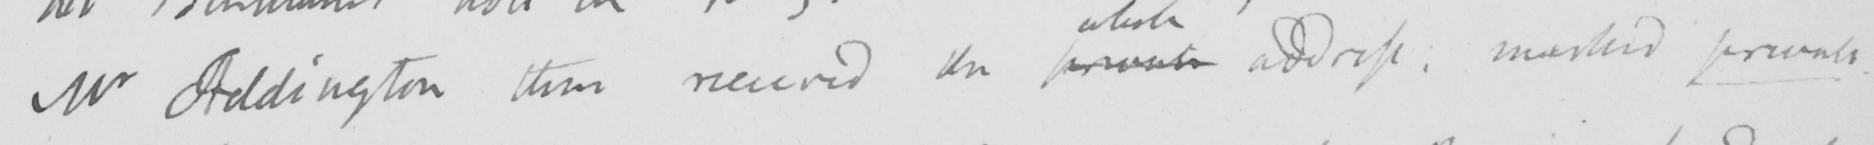What text is written in this handwritten line? Mr Addington then received the private address :  marked private . 